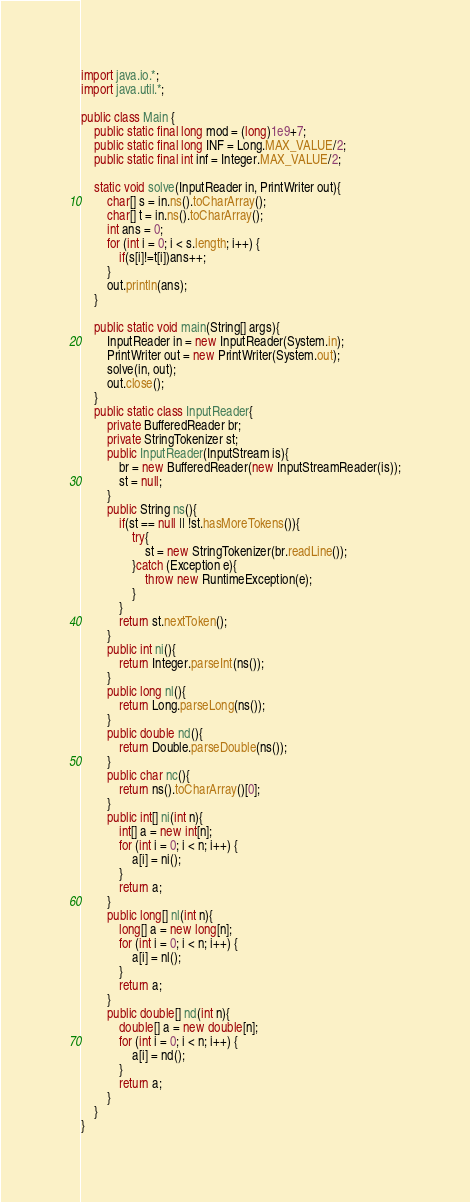<code> <loc_0><loc_0><loc_500><loc_500><_Java_>import java.io.*;
import java.util.*;

public class Main {
    public static final long mod = (long)1e9+7;
    public static final long INF = Long.MAX_VALUE/2;
    public static final int inf = Integer.MAX_VALUE/2;

    static void solve(InputReader in, PrintWriter out){
        char[] s = in.ns().toCharArray();
        char[] t = in.ns().toCharArray();
        int ans = 0;
        for (int i = 0; i < s.length; i++) {
            if(s[i]!=t[i])ans++;
        }
        out.println(ans);
    }

    public static void main(String[] args){
        InputReader in = new InputReader(System.in);
        PrintWriter out = new PrintWriter(System.out);
        solve(in, out);
        out.close();
    }
    public static class InputReader{
        private BufferedReader br;
        private StringTokenizer st;
        public InputReader(InputStream is){
            br = new BufferedReader(new InputStreamReader(is));
            st = null;
        }
        public String ns(){
            if(st == null || !st.hasMoreTokens()){
                try{
                    st = new StringTokenizer(br.readLine());
                }catch (Exception e){
                    throw new RuntimeException(e);
                }
            }
            return st.nextToken();
        }
        public int ni(){
            return Integer.parseInt(ns());
        }
        public long nl(){
            return Long.parseLong(ns());
        }
        public double nd(){
            return Double.parseDouble(ns());
        }
        public char nc(){
            return ns().toCharArray()[0];
        }
        public int[] ni(int n){
            int[] a = new int[n];
            for (int i = 0; i < n; i++) {
                a[i] = ni();
            }
            return a;
        }
        public long[] nl(int n){
            long[] a = new long[n];
            for (int i = 0; i < n; i++) {
                a[i] = nl();
            }
            return a;
        }
        public double[] nd(int n){
            double[] a = new double[n];
            for (int i = 0; i < n; i++) {
                a[i] = nd();
            }
            return a;
        }
    }
}</code> 